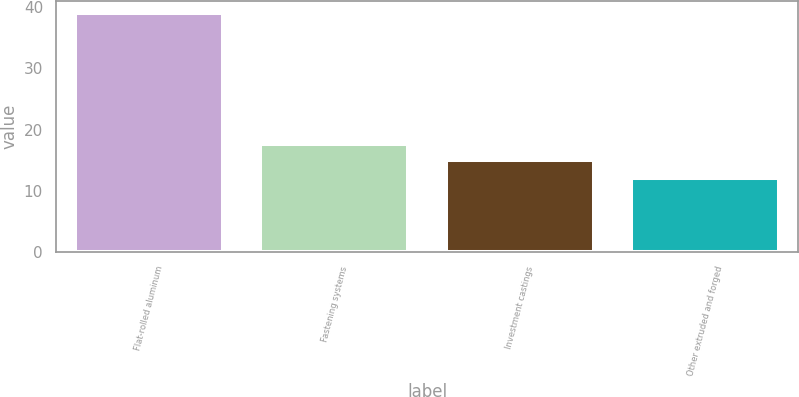Convert chart to OTSL. <chart><loc_0><loc_0><loc_500><loc_500><bar_chart><fcel>Flat-rolled aluminum<fcel>Fastening systems<fcel>Investment castings<fcel>Other extruded and forged<nl><fcel>39<fcel>17.7<fcel>15<fcel>12<nl></chart> 